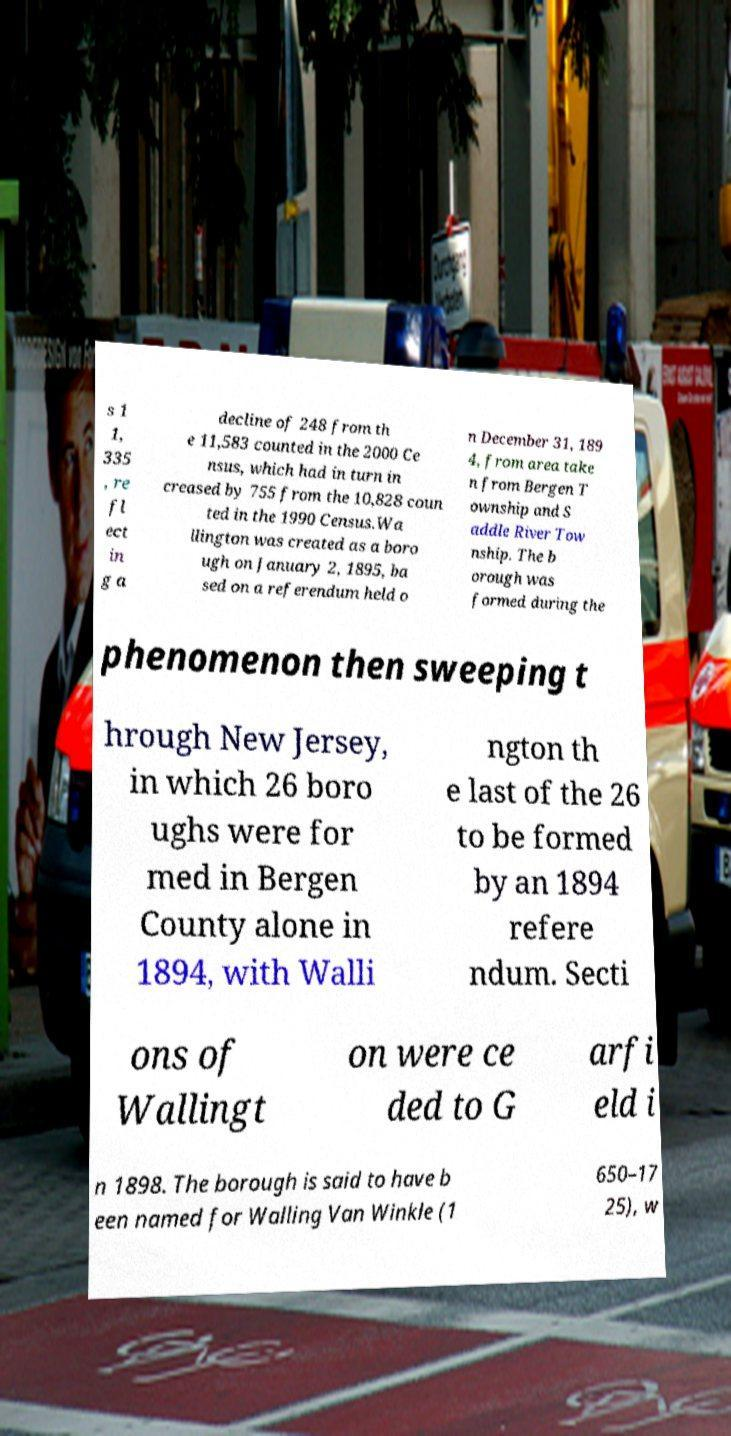Please read and relay the text visible in this image. What does it say? s 1 1, 335 , re fl ect in g a decline of 248 from th e 11,583 counted in the 2000 Ce nsus, which had in turn in creased by 755 from the 10,828 coun ted in the 1990 Census.Wa llington was created as a boro ugh on January 2, 1895, ba sed on a referendum held o n December 31, 189 4, from area take n from Bergen T ownship and S addle River Tow nship. The b orough was formed during the phenomenon then sweeping t hrough New Jersey, in which 26 boro ughs were for med in Bergen County alone in 1894, with Walli ngton th e last of the 26 to be formed by an 1894 refere ndum. Secti ons of Wallingt on were ce ded to G arfi eld i n 1898. The borough is said to have b een named for Walling Van Winkle (1 650–17 25), w 